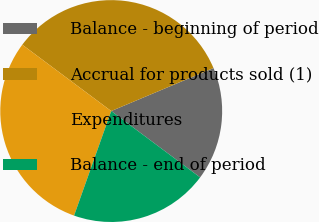<chart> <loc_0><loc_0><loc_500><loc_500><pie_chart><fcel>Balance - beginning of period<fcel>Accrual for products sold (1)<fcel>Expenditures<fcel>Balance - end of period<nl><fcel>16.54%<fcel>33.46%<fcel>29.77%<fcel>20.23%<nl></chart> 